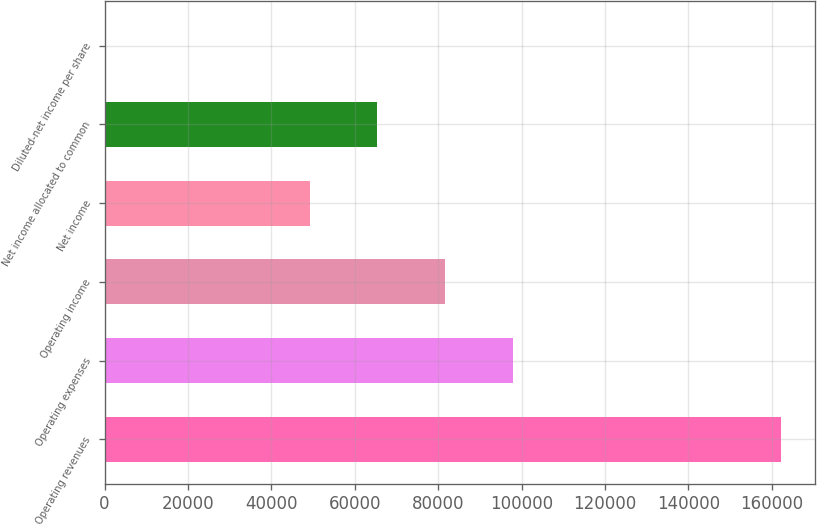Convert chart. <chart><loc_0><loc_0><loc_500><loc_500><bar_chart><fcel>Operating revenues<fcel>Operating expenses<fcel>Operating income<fcel>Net income<fcel>Net income allocated to common<fcel>Diluted-net income per share<nl><fcel>162330<fcel>97874.8<fcel>81641.9<fcel>49176<fcel>65408.9<fcel>0.6<nl></chart> 